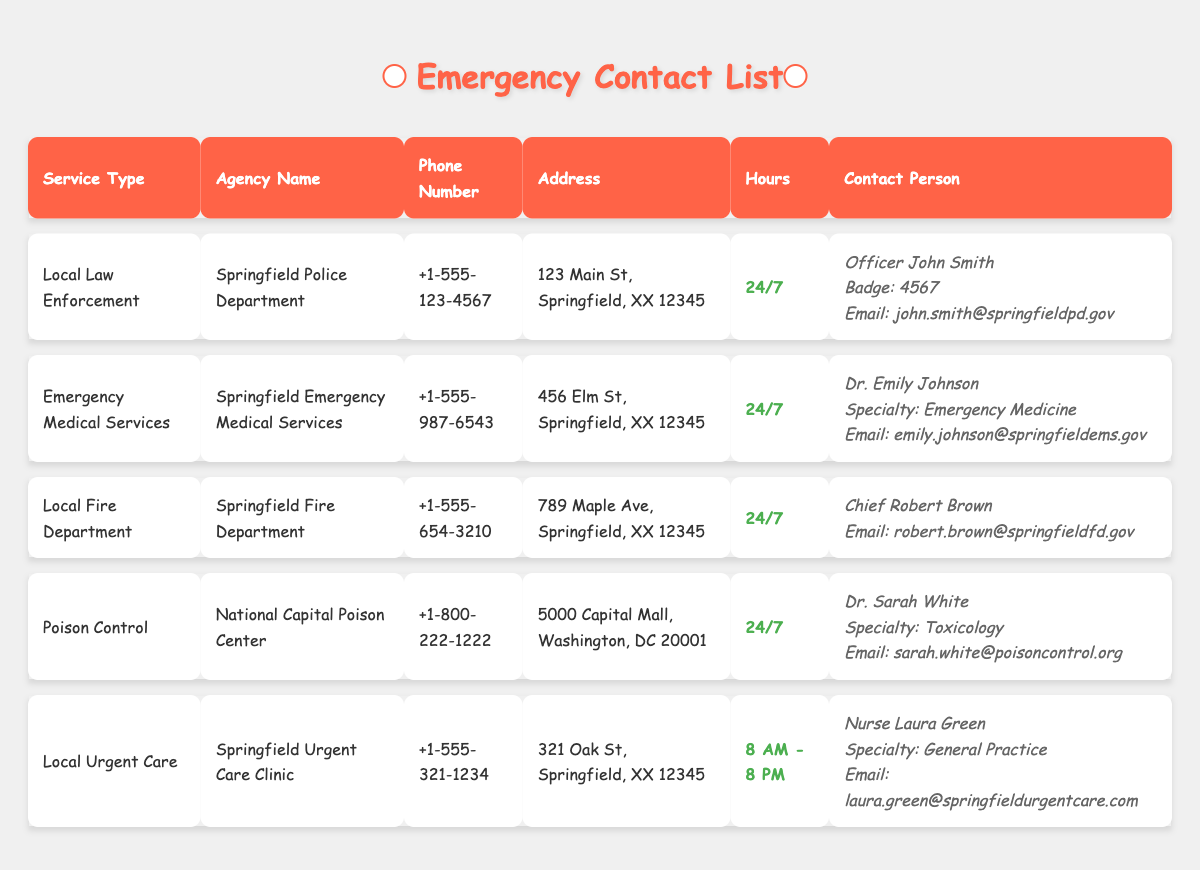What is the phone number for the Springfield Fire Department? The phone number for the Springfield Fire Department is listed in the table under the column "Phone Number". It shows +1-555-654-3210.
Answer: +1-555-654-3210 Who is the contact person for the Poison Control agency? The contact person for the Poison Control agency is listed under the "Contact Person" column for the National Capital Poison Center. The entry specifies that Dr. Sarah White is the contact person.
Answer: Dr. Sarah White Is the Springfield Urgent Care Clinic open 24/7? The Springfield Urgent Care Clinic's hours are listed in the "Hours" column. It shows "8 AM - 8 PM", which indicates it is not open 24/7.
Answer: No Which agency has an email contact of laura.green@springfieldurgentcare.com? The email address laura.green@springfieldurgentcare.com is found in the "Contact Person" column for the Springfield Urgent Care Clinic. This indicates that the agency is Springfield Urgent Care Clinic.
Answer: Springfield Urgent Care Clinic How many agencies provide services 24/7? To find the number of agencies providing 24/7 services, we can review the "Hours" column. There are four agencies that list their hours as 24/7, namely Springfield Police Department, Springfield Emergency Medical Services, Springfield Fire Department, and National Capital Poison Center. Therefore, counting these gives us a total of 4.
Answer: 4 Which agency has the specialty of Toxicology? The agency that lists a contact with a specialty of Toxicology is the National Capital Poison Center. This is found in the "Contact Person" column where Dr. Sarah White is identified with this specialty.
Answer: National Capital Poison Center What is the average response time you could expect from agencies that are open 24/7 compared to those that are not? The table indicates that there are four agencies open 24/7 (Springfield Police Department, Springfield Emergency Medical Services, Springfield Fire Department, and National Capital Poison Center) and one that is not (Springfield Urgent Care Clinic open from 8 AM to 8 PM). The concept of average response time is not provided in the data; thus, we cannot answer this without additional information.
Answer: Not available Is Officer John Smith associated with the Springfield Police Department? The table indicates that Officer John Smith is specifically listed under the "Contact Person" for the Springfield Police Department, confirming the association.
Answer: Yes What are the office hours for The Springfield Emergency Medical Services? The "Hours" column for the Springfield Emergency Medical Services indicates the office hours as 24/7, meaning they are always available, day and night.
Answer: 24/7 